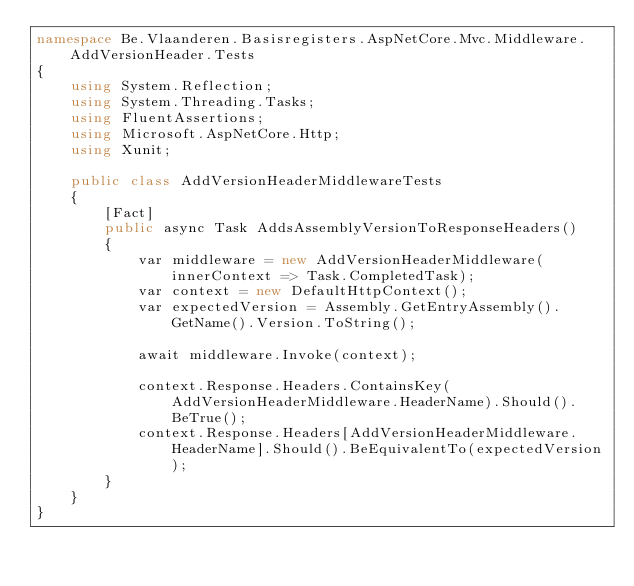<code> <loc_0><loc_0><loc_500><loc_500><_C#_>namespace Be.Vlaanderen.Basisregisters.AspNetCore.Mvc.Middleware.AddVersionHeader.Tests
{
    using System.Reflection;
    using System.Threading.Tasks;
    using FluentAssertions;
    using Microsoft.AspNetCore.Http;
    using Xunit;

    public class AddVersionHeaderMiddlewareTests
    {
        [Fact]
        public async Task AddsAssemblyVersionToResponseHeaders()
        {
            var middleware = new AddVersionHeaderMiddleware(innerContext => Task.CompletedTask);
            var context = new DefaultHttpContext();
            var expectedVersion = Assembly.GetEntryAssembly().GetName().Version.ToString();

            await middleware.Invoke(context);

            context.Response.Headers.ContainsKey(AddVersionHeaderMiddleware.HeaderName).Should().BeTrue();
            context.Response.Headers[AddVersionHeaderMiddleware.HeaderName].Should().BeEquivalentTo(expectedVersion);
        }
    }
}
</code> 